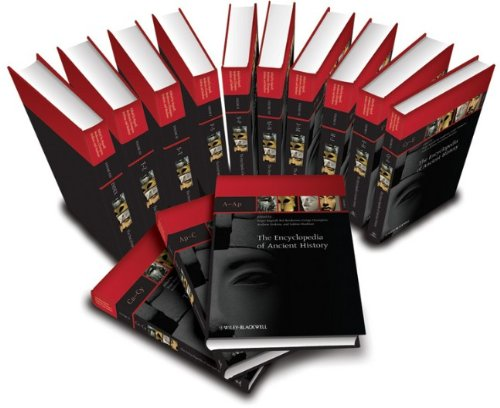Can you describe one of the key historical topics covered in this encyclopedia? One key topic covered is the Roman Empire, detailing its rise, governance, cultural influences, and eventual decline. The volumes provide in-depth analyses and primary sources, making it a rich resource for understanding this powerful empire's impact on history. 